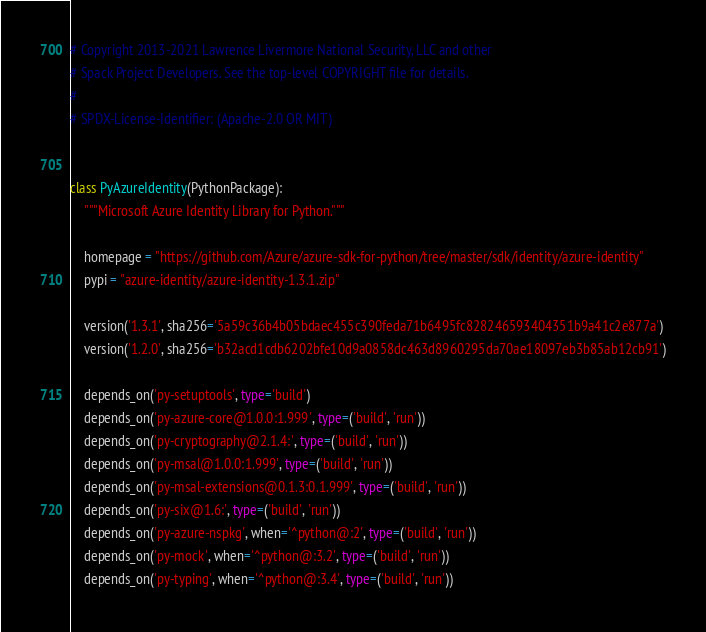Convert code to text. <code><loc_0><loc_0><loc_500><loc_500><_Python_># Copyright 2013-2021 Lawrence Livermore National Security, LLC and other
# Spack Project Developers. See the top-level COPYRIGHT file for details.
#
# SPDX-License-Identifier: (Apache-2.0 OR MIT)


class PyAzureIdentity(PythonPackage):
    """Microsoft Azure Identity Library for Python."""

    homepage = "https://github.com/Azure/azure-sdk-for-python/tree/master/sdk/identity/azure-identity"
    pypi = "azure-identity/azure-identity-1.3.1.zip"

    version('1.3.1', sha256='5a59c36b4b05bdaec455c390feda71b6495fc828246593404351b9a41c2e877a')
    version('1.2.0', sha256='b32acd1cdb6202bfe10d9a0858dc463d8960295da70ae18097eb3b85ab12cb91')

    depends_on('py-setuptools', type='build')
    depends_on('py-azure-core@1.0.0:1.999', type=('build', 'run'))
    depends_on('py-cryptography@2.1.4:', type=('build', 'run'))
    depends_on('py-msal@1.0.0:1.999', type=('build', 'run'))
    depends_on('py-msal-extensions@0.1.3:0.1.999', type=('build', 'run'))
    depends_on('py-six@1.6:', type=('build', 'run'))
    depends_on('py-azure-nspkg', when='^python@:2', type=('build', 'run'))
    depends_on('py-mock', when='^python@:3.2', type=('build', 'run'))
    depends_on('py-typing', when='^python@:3.4', type=('build', 'run'))
</code> 